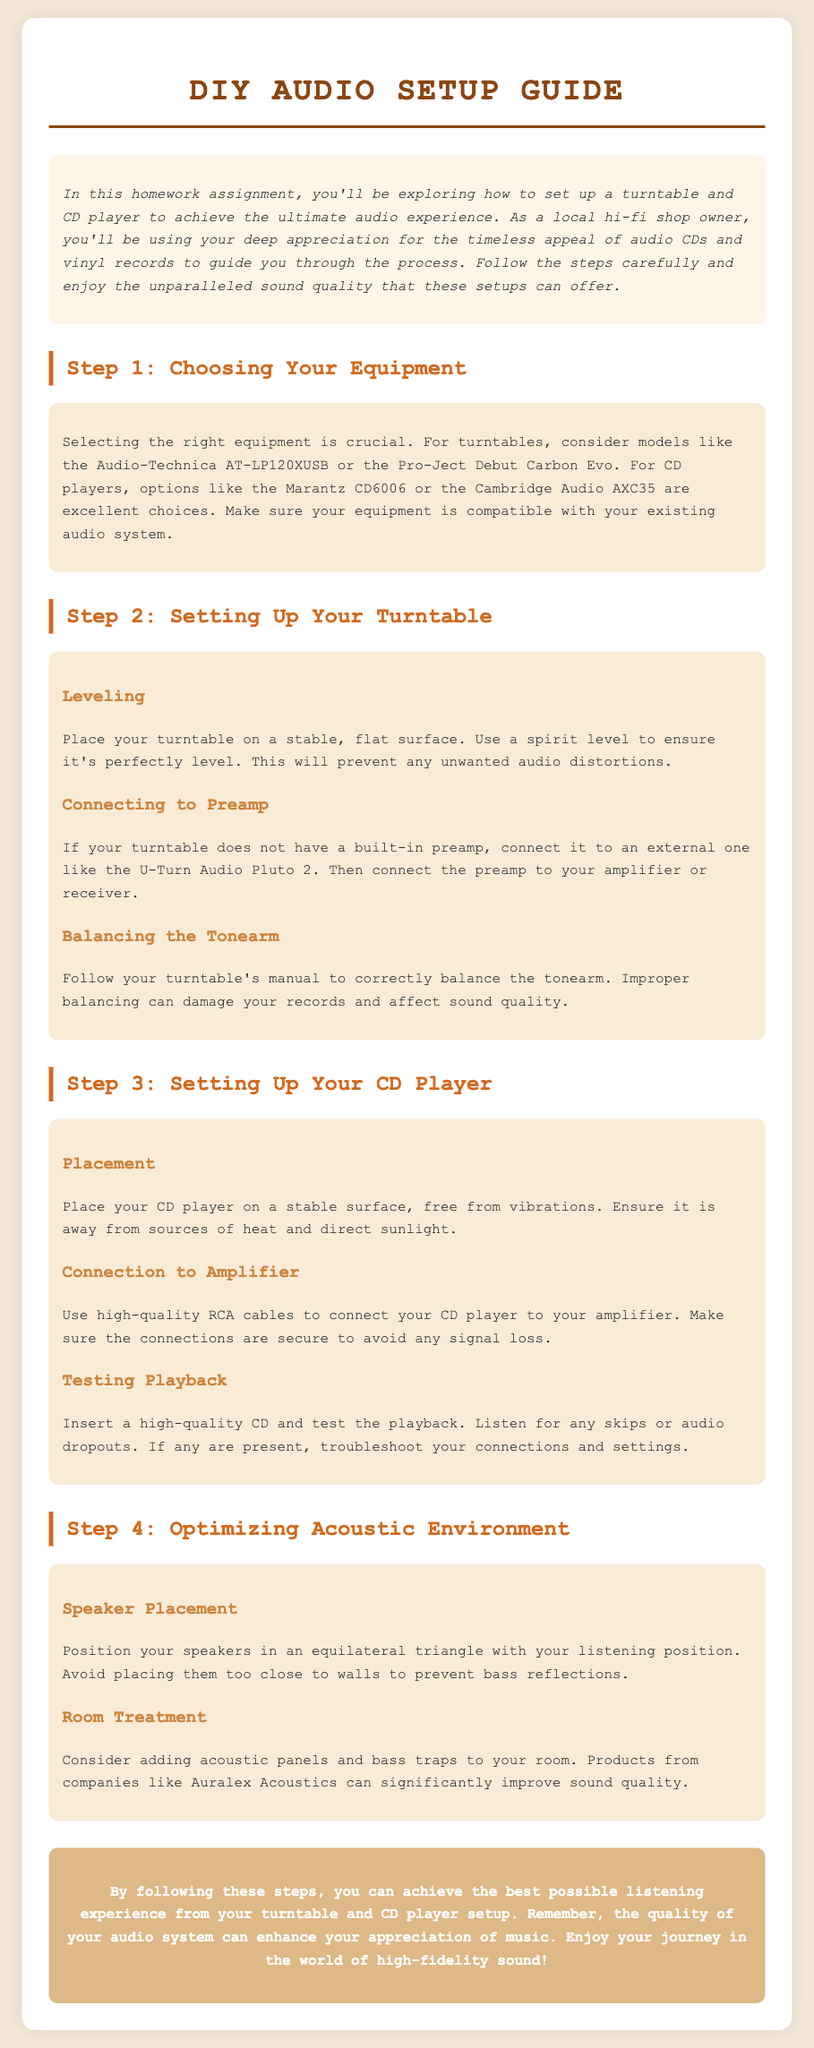what is the title of the guide? The title can be found at the top of the document in a large font.
Answer: DIY Audio Setup Guide what is the main focus of the document? The main focus is mentioned in the introductory paragraph, highlighting the exploration of audio equipment setup.
Answer: Setting up a turntable and CD player which turntable model is recommended? The document lists specific models under the section on choosing equipment.
Answer: Audio-Technica AT-LP120XUSB what should be avoided when placing speakers? The document outlines recommendations for speaker placement to enhance sound quality.
Answer: Too close to walls what is a suggested product for room treatment? The document mentions a specific brand that can improve acoustic environments.
Answer: Auralex Acoustics how are speakers recommended to be arranged? The document provides a guideline on speaker arrangement for optimal listening.
Answer: Equilateral triangle what is used to connect the CD player to the amplifier? The section on setting up the CD player specifies the type of cable to use.
Answer: RCA cables what is the first step in the setup process? The document organizes the setup process into steps, starting with equipment choice.
Answer: Choosing Your Equipment how should the turntable be placed? The section on setting up the turntable mentions the importance of a stable surface.
Answer: Stable, flat surface 